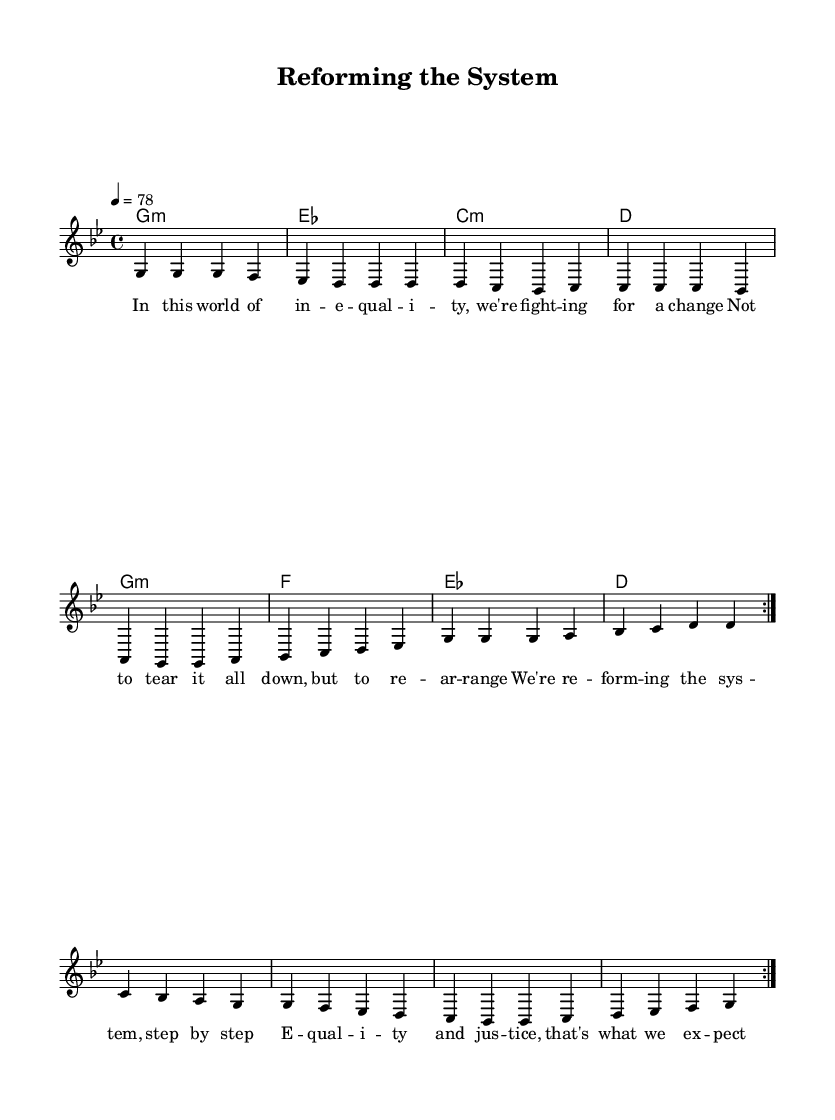What is the key signature of this music? The key signature is G minor, which has two flats (B flat and E flat). It indicates that the notes played in this piece revolve around the G minor scale.
Answer: G minor What is the time signature of this piece? The time signature is 4/4, meaning there are four beats in each measure and the quarter note gets one beat. This is a common time signature in reggae music, providing a steady rhythmic flow.
Answer: 4/4 What is the tempo marking of this composition? The tempo is marked at 78 beats per minute, which suggests a moderate pace suitable for reggae, allowing for a relaxed groove while maintaining movement.
Answer: 78 How many times does the melody repeat according to the sheet music? The melody repeats two times as indicated by the "\repeat volta 2" notation, which instructs the musician to revisit that section twice.
Answer: 2 What message does the lyrics convey about social justice? The lyrics advocate for change within the system rather than dismantling it, emphasizing reform towards equality and justice. This aligns with the idea of improving conditions within a capitalist framework.
Answer: Reforming the system What type of chords are primarily used in this piece? The piece predominantly uses minor chords, which are often associated with a more introspective and serious mood in reggae, aligning with the theme of social justice.
Answer: Minor What musical genre does this song represent and what is its social context? The song represents reggae, a genre that often addresses social issues and justice, making it a fitting vehicle for discussions on reforming capitalism rather than overthrowing it.
Answer: Reggae 